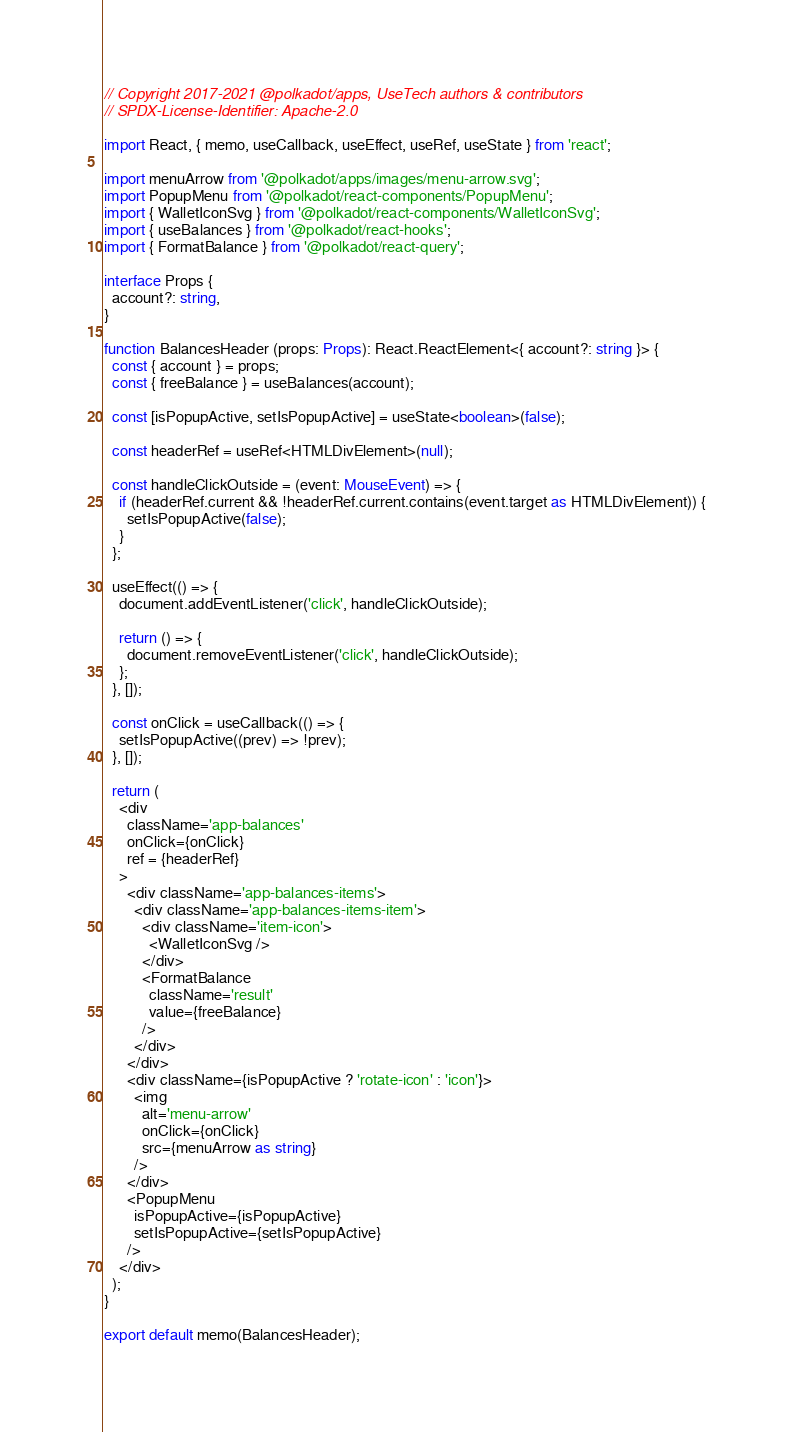Convert code to text. <code><loc_0><loc_0><loc_500><loc_500><_TypeScript_>// Copyright 2017-2021 @polkadot/apps, UseTech authors & contributors
// SPDX-License-Identifier: Apache-2.0

import React, { memo, useCallback, useEffect, useRef, useState } from 'react';

import menuArrow from '@polkadot/apps/images/menu-arrow.svg';
import PopupMenu from '@polkadot/react-components/PopupMenu';
import { WalletIconSvg } from '@polkadot/react-components/WalletIconSvg';
import { useBalances } from '@polkadot/react-hooks';
import { FormatBalance } from '@polkadot/react-query';

interface Props {
  account?: string,
}

function BalancesHeader (props: Props): React.ReactElement<{ account?: string }> {
  const { account } = props;
  const { freeBalance } = useBalances(account);

  const [isPopupActive, setIsPopupActive] = useState<boolean>(false);

  const headerRef = useRef<HTMLDivElement>(null);

  const handleClickOutside = (event: MouseEvent) => {
    if (headerRef.current && !headerRef.current.contains(event.target as HTMLDivElement)) {
      setIsPopupActive(false);
    }
  };

  useEffect(() => {
    document.addEventListener('click', handleClickOutside);

    return () => {
      document.removeEventListener('click', handleClickOutside);
    };
  }, []);

  const onClick = useCallback(() => {
    setIsPopupActive((prev) => !prev);
  }, []);

  return (
    <div
      className='app-balances'
      onClick={onClick}
      ref = {headerRef}
    >
      <div className='app-balances-items'>
        <div className='app-balances-items-item'>
          <div className='item-icon'>
            <WalletIconSvg />
          </div>
          <FormatBalance
            className='result'
            value={freeBalance}
          />
        </div>
      </div>
      <div className={isPopupActive ? 'rotate-icon' : 'icon'}>
        <img
          alt='menu-arrow'
          onClick={onClick}
          src={menuArrow as string}
        />
      </div>
      <PopupMenu
        isPopupActive={isPopupActive}
        setIsPopupActive={setIsPopupActive}
      />
    </div>
  );
}

export default memo(BalancesHeader);
</code> 